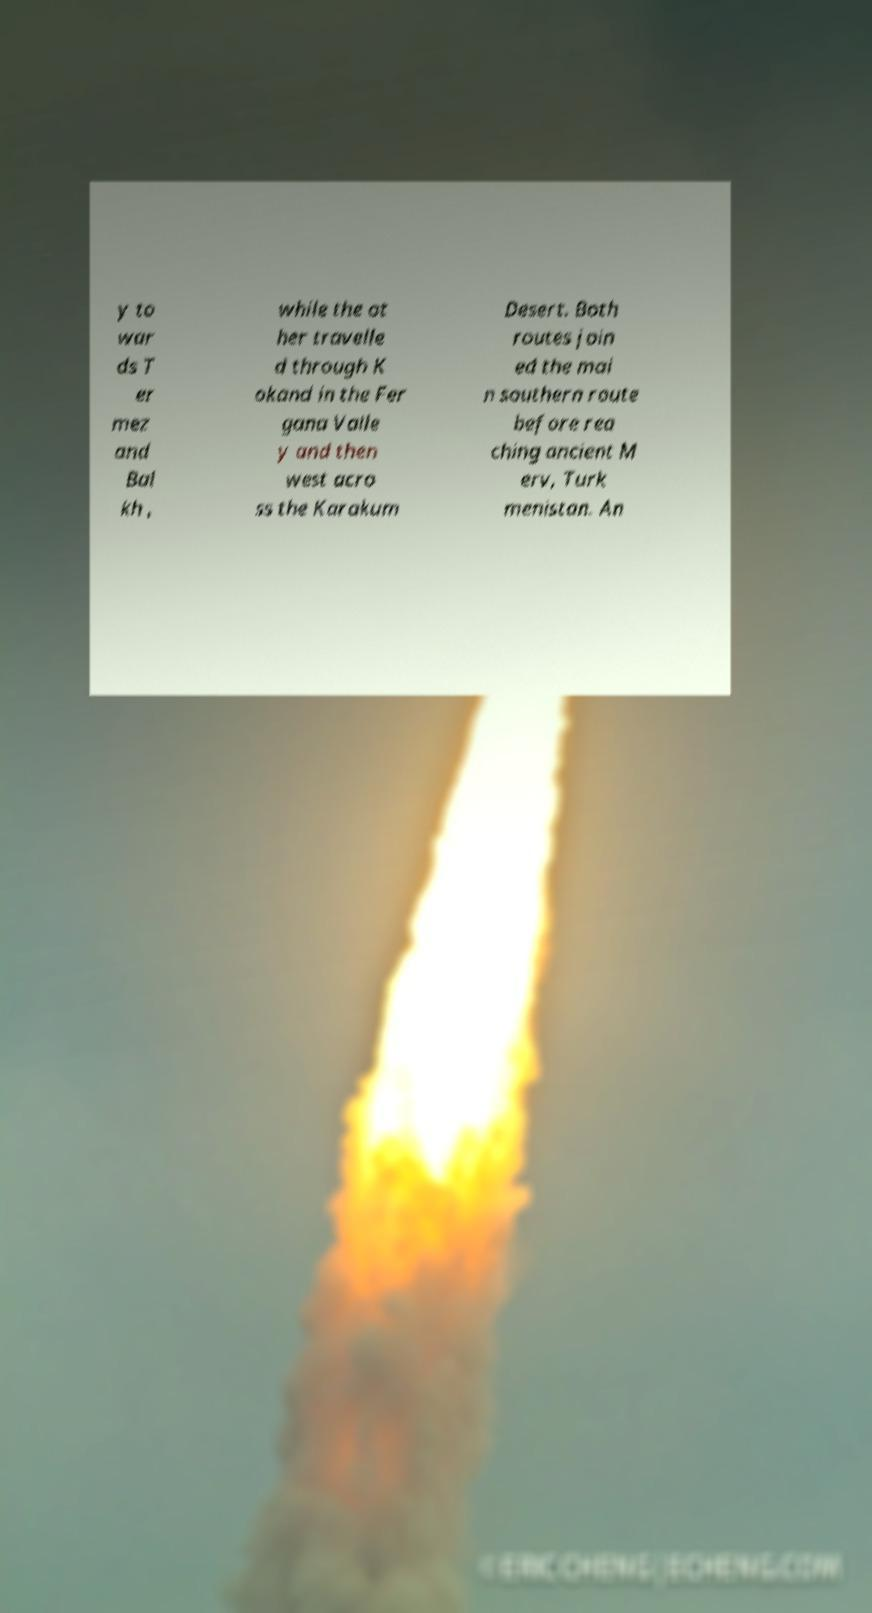Please read and relay the text visible in this image. What does it say? y to war ds T er mez and Bal kh , while the ot her travelle d through K okand in the Fer gana Valle y and then west acro ss the Karakum Desert. Both routes join ed the mai n southern route before rea ching ancient M erv, Turk menistan. An 